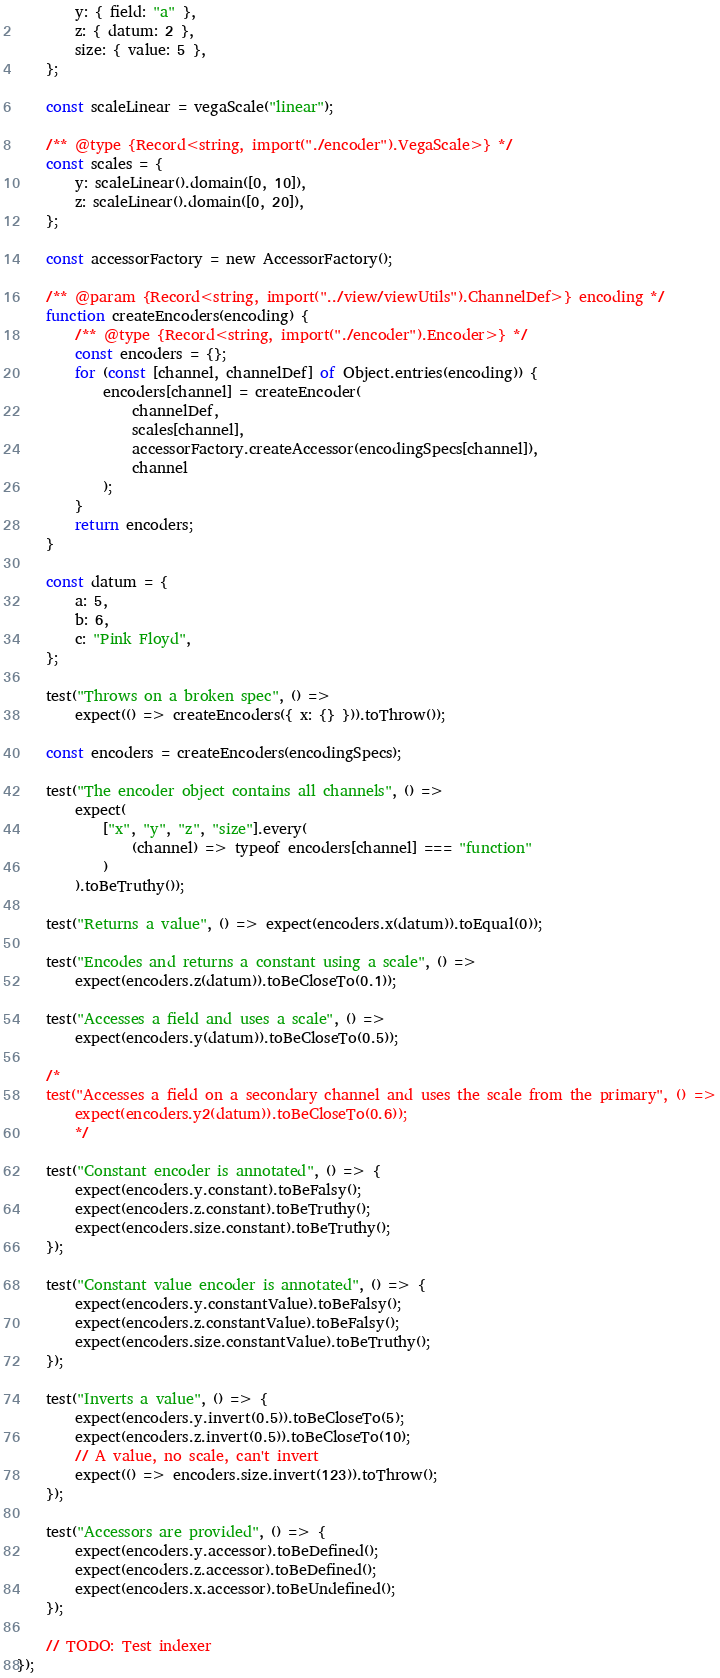<code> <loc_0><loc_0><loc_500><loc_500><_JavaScript_>        y: { field: "a" },
        z: { datum: 2 },
        size: { value: 5 },
    };

    const scaleLinear = vegaScale("linear");

    /** @type {Record<string, import("./encoder").VegaScale>} */
    const scales = {
        y: scaleLinear().domain([0, 10]),
        z: scaleLinear().domain([0, 20]),
    };

    const accessorFactory = new AccessorFactory();

    /** @param {Record<string, import("../view/viewUtils").ChannelDef>} encoding */
    function createEncoders(encoding) {
        /** @type {Record<string, import("./encoder").Encoder>} */
        const encoders = {};
        for (const [channel, channelDef] of Object.entries(encoding)) {
            encoders[channel] = createEncoder(
                channelDef,
                scales[channel],
                accessorFactory.createAccessor(encodingSpecs[channel]),
                channel
            );
        }
        return encoders;
    }

    const datum = {
        a: 5,
        b: 6,
        c: "Pink Floyd",
    };

    test("Throws on a broken spec", () =>
        expect(() => createEncoders({ x: {} })).toThrow());

    const encoders = createEncoders(encodingSpecs);

    test("The encoder object contains all channels", () =>
        expect(
            ["x", "y", "z", "size"].every(
                (channel) => typeof encoders[channel] === "function"
            )
        ).toBeTruthy());

    test("Returns a value", () => expect(encoders.x(datum)).toEqual(0));

    test("Encodes and returns a constant using a scale", () =>
        expect(encoders.z(datum)).toBeCloseTo(0.1));

    test("Accesses a field and uses a scale", () =>
        expect(encoders.y(datum)).toBeCloseTo(0.5));

    /*
    test("Accesses a field on a secondary channel and uses the scale from the primary", () =>
        expect(encoders.y2(datum)).toBeCloseTo(0.6));
        */

    test("Constant encoder is annotated", () => {
        expect(encoders.y.constant).toBeFalsy();
        expect(encoders.z.constant).toBeTruthy();
        expect(encoders.size.constant).toBeTruthy();
    });

    test("Constant value encoder is annotated", () => {
        expect(encoders.y.constantValue).toBeFalsy();
        expect(encoders.z.constantValue).toBeFalsy();
        expect(encoders.size.constantValue).toBeTruthy();
    });

    test("Inverts a value", () => {
        expect(encoders.y.invert(0.5)).toBeCloseTo(5);
        expect(encoders.z.invert(0.5)).toBeCloseTo(10);
        // A value, no scale, can't invert
        expect(() => encoders.size.invert(123)).toThrow();
    });

    test("Accessors are provided", () => {
        expect(encoders.y.accessor).toBeDefined();
        expect(encoders.z.accessor).toBeDefined();
        expect(encoders.x.accessor).toBeUndefined();
    });

    // TODO: Test indexer
});
</code> 